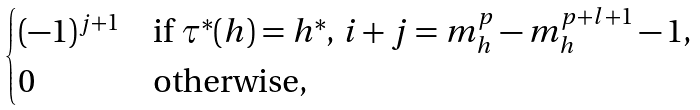Convert formula to latex. <formula><loc_0><loc_0><loc_500><loc_500>\begin{cases} ( - 1 ) ^ { j + 1 } & \text {if $\tau^{\ast}(h)=h^{\ast}$, $i+j=m_{h}^{p}-m_{h}^{p+l+1}-1$,} \\ 0 & \text {otherwise,} \end{cases}</formula> 